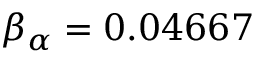Convert formula to latex. <formula><loc_0><loc_0><loc_500><loc_500>\beta _ { \alpha } = 0 . 0 4 6 6 7</formula> 